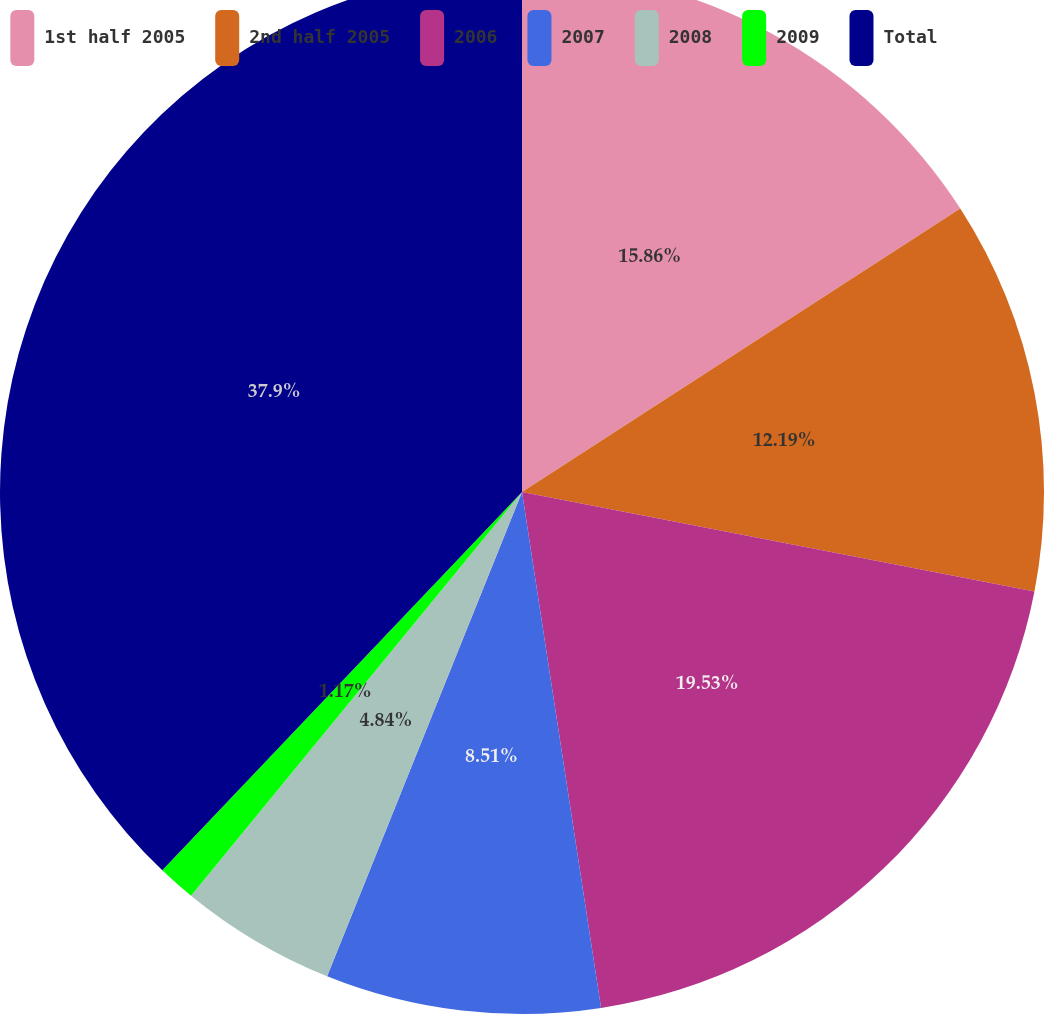Convert chart to OTSL. <chart><loc_0><loc_0><loc_500><loc_500><pie_chart><fcel>1st half 2005<fcel>2nd half 2005<fcel>2006<fcel>2007<fcel>2008<fcel>2009<fcel>Total<nl><fcel>15.86%<fcel>12.19%<fcel>19.53%<fcel>8.51%<fcel>4.84%<fcel>1.17%<fcel>37.9%<nl></chart> 